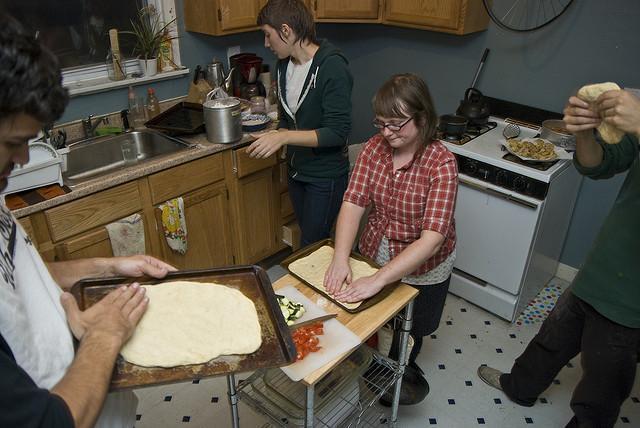How many people are there?
Give a very brief answer. 5. How many sinks are visible?
Give a very brief answer. 1. 